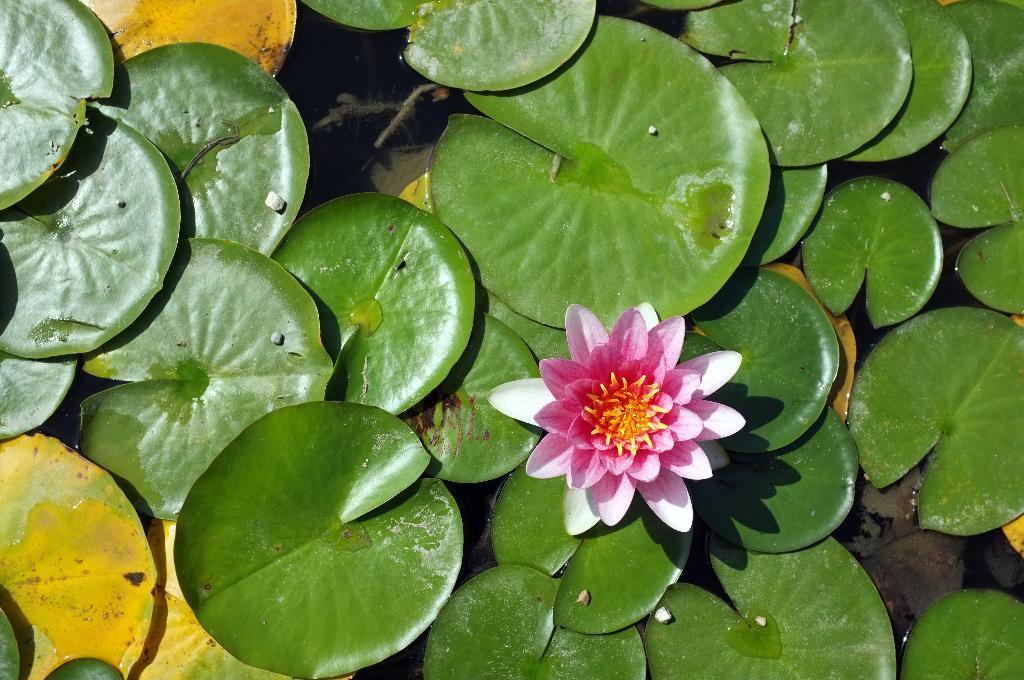How would you summarize this image in a sentence or two? In this image we can see few leaves and a flower floating on the water. 